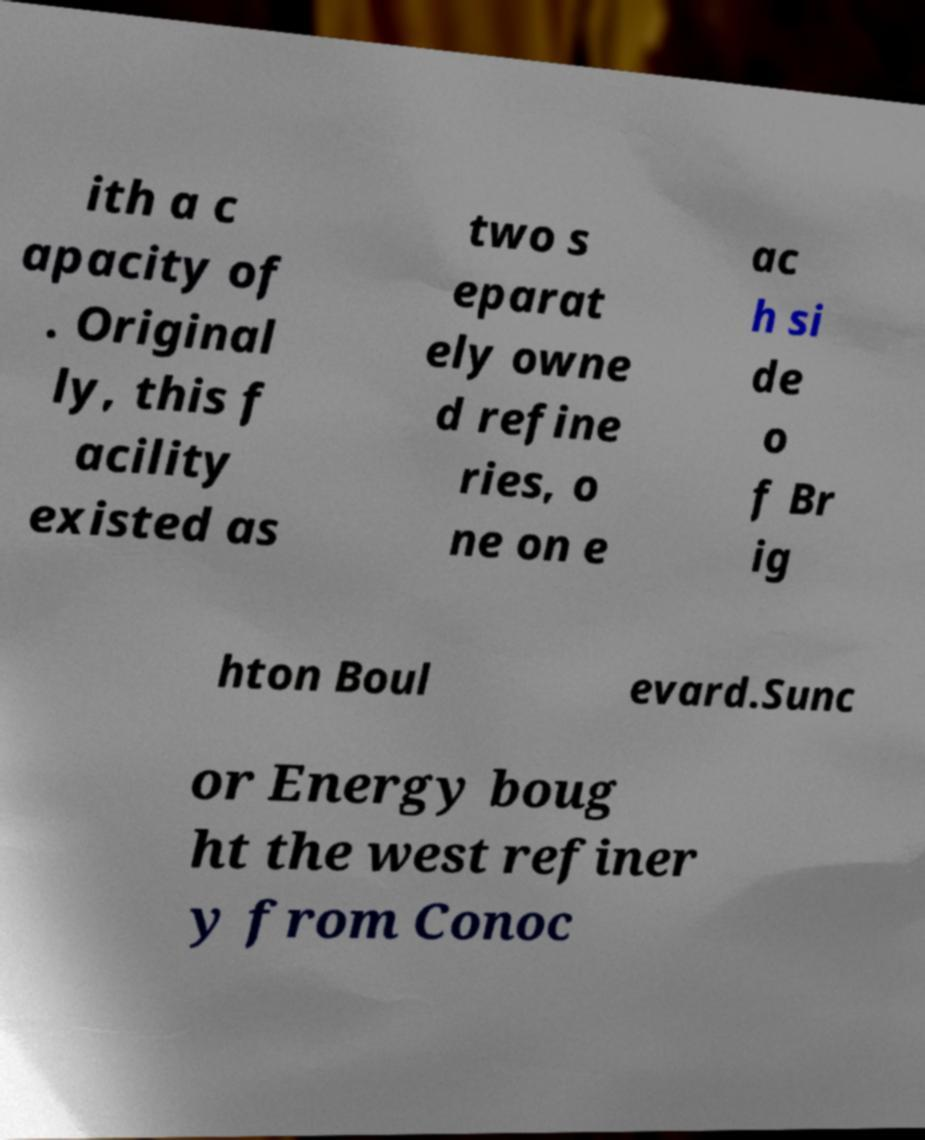I need the written content from this picture converted into text. Can you do that? ith a c apacity of . Original ly, this f acility existed as two s eparat ely owne d refine ries, o ne on e ac h si de o f Br ig hton Boul evard.Sunc or Energy boug ht the west refiner y from Conoc 